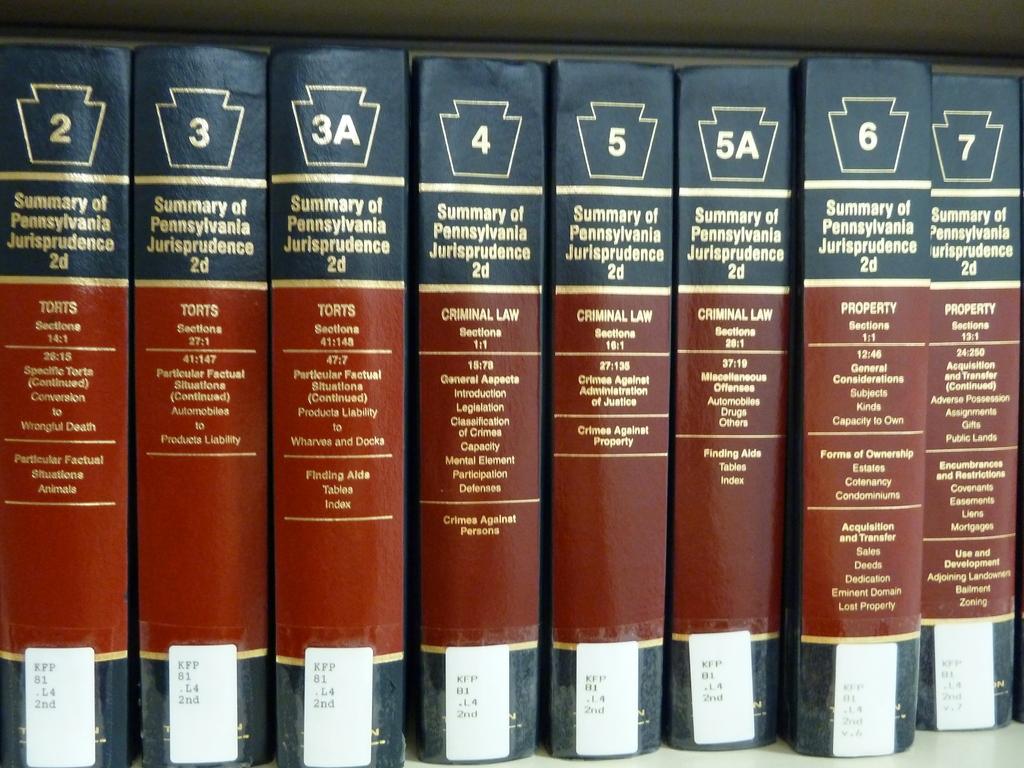Which is the lowest volume number?
Give a very brief answer. 2. 